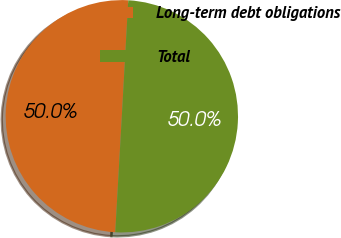Convert chart to OTSL. <chart><loc_0><loc_0><loc_500><loc_500><pie_chart><fcel>Long-term debt obligations<fcel>Total<nl><fcel>49.98%<fcel>50.02%<nl></chart> 